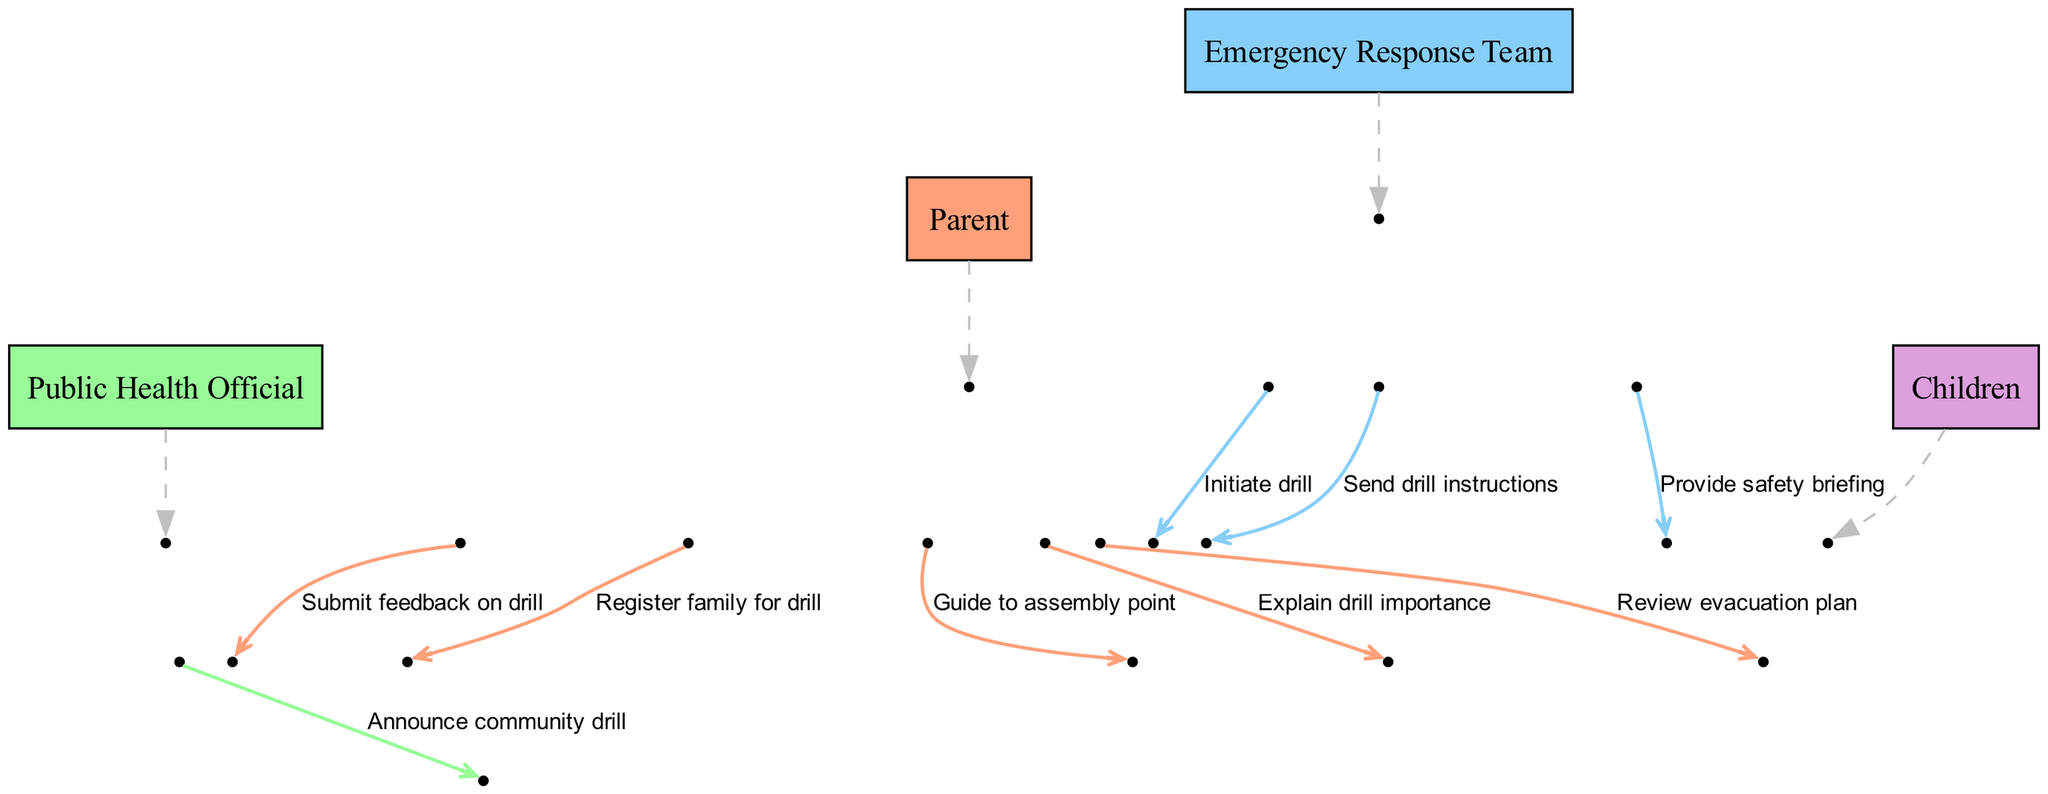What is the first message shown in the diagram? The first message in the sequence is from the Public Health Official to the Parent, stating "Announce community drill." This is clearly indicated as the first step in the sequence.
Answer: Announce community drill How many actors are depicted in the diagram? The diagram lists four distinct actors involved in the sequence: Parent, Public Health Official, Emergency Response Team, and Children. The count of actors can be directly observed in the actor list.
Answer: Four Which actor sends drill instructions to the Parent? The Emergency Response Team is responsible for sending drill instructions to the Parent, as indicated in the sequence step where they directly communicate with the Parent.
Answer: Emergency Response Team What is the second-to-last message in the sequence? The second-to-last message is from the Parent to the Public Health Official, where the Parent submits feedback on the drill. This order can be traced through the sequence steps.
Answer: Submit feedback on drill Who does the Parent explain the drill's importance to? The Parent explains the drill's importance specifically to the Children. This can be confirmed by observing the message directed from the Parent to the Children in the sequence.
Answer: Children How many messages are exchanged between the Parent and the Emergency Response Team? Two messages are exchanged: the Emergency Response Team sends drill instructions to the Parent, and then they provide a safety briefing. To reach this conclusion, each interaction must be counted within the sequence.
Answer: Two What action does the Parent take right after initiating the drill? After the drill is initiated, the Parent guides the Children to the assembly point. This sequence of actions shows the direct response following the initiation of the drill.
Answer: Guide to assembly point Which actor receives feedback on the drill? The Parent submits feedback on the drill to the Public Health Official. This information can be extracted from the last interaction in the sequence of messages.
Answer: Public Health Official 